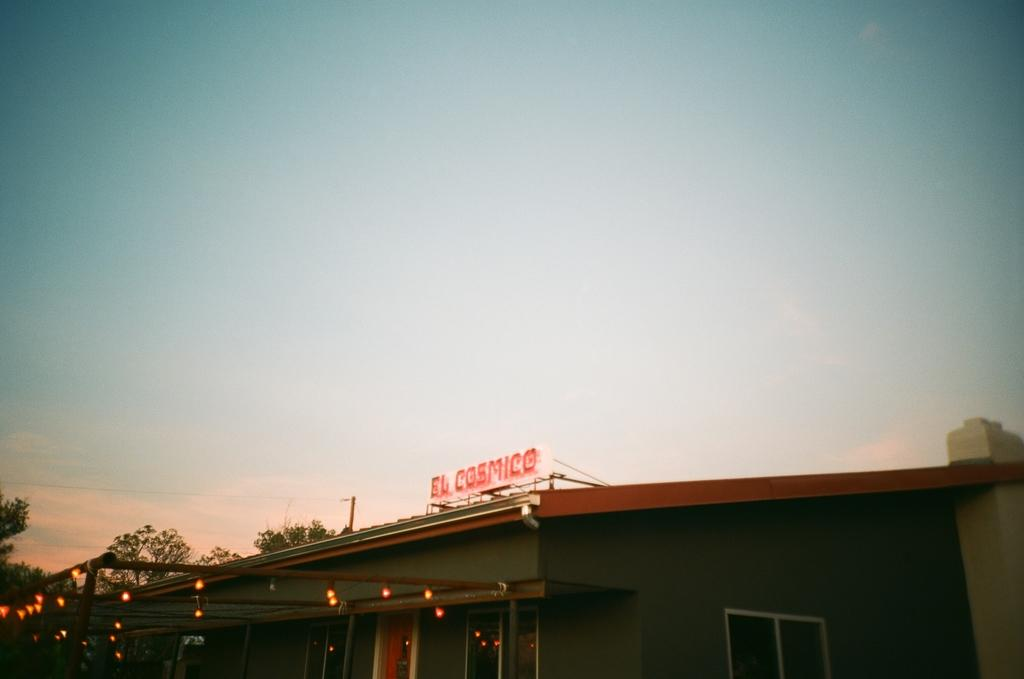What type of structure is present in the image? There is a building in the image. What can be seen on the poles in the image? Lights are visible on poles in the image. What type of vegetation is in the background of the image? There are trees in the background of the image. What color is the sky in the image? The sky is blue in color. What type of floor can be seen in the image? There is no floor visible in the image; it is an outdoor scene with a building, lights, trees, and a blue sky. 